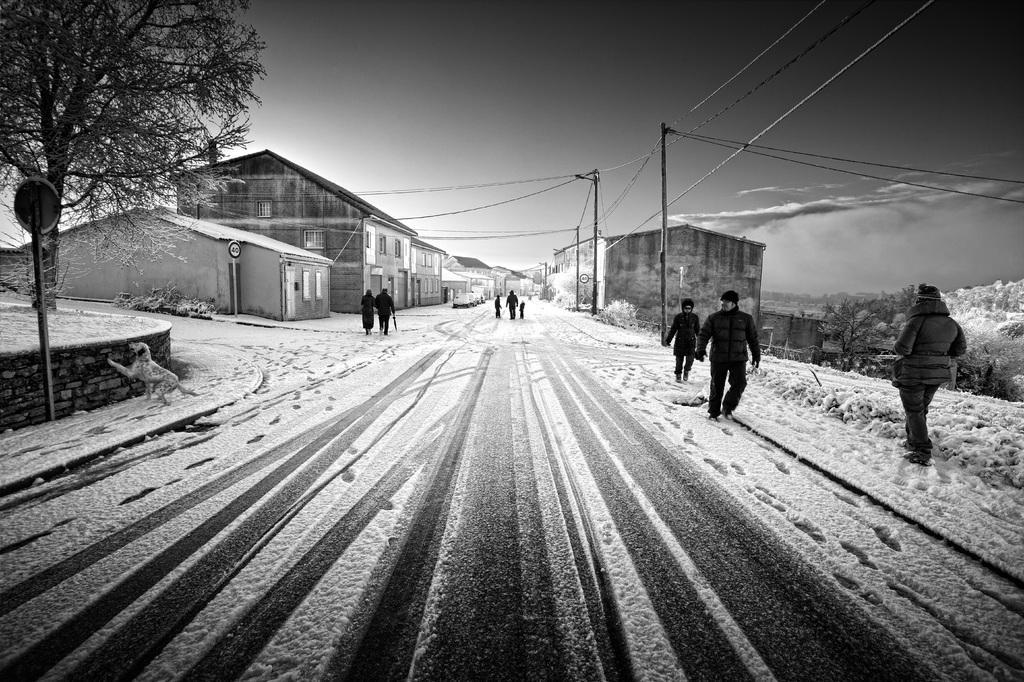Can you describe this image briefly? In this picture we can see group of people, few poles, cables and buildings, and also we can see few trees, sign boards, snow and a dog, and it is a black and white photography. 